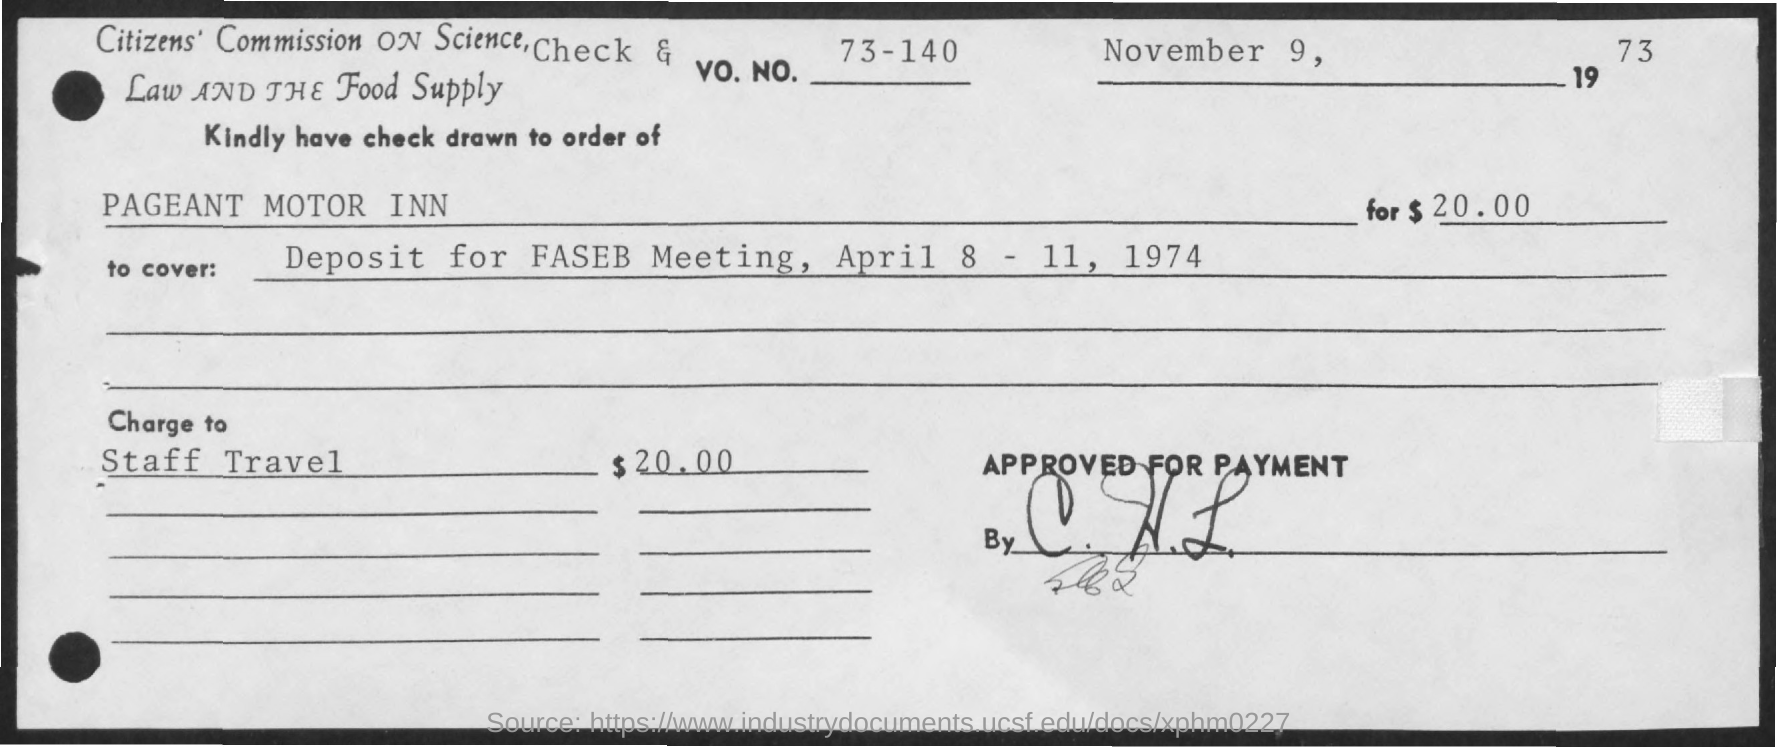What is the Vo. No.?
Give a very brief answer. 73-140. What is the date?
Offer a terse response. November 9, 1973. What is the amount mentioned?
Make the answer very short. $20.00. 